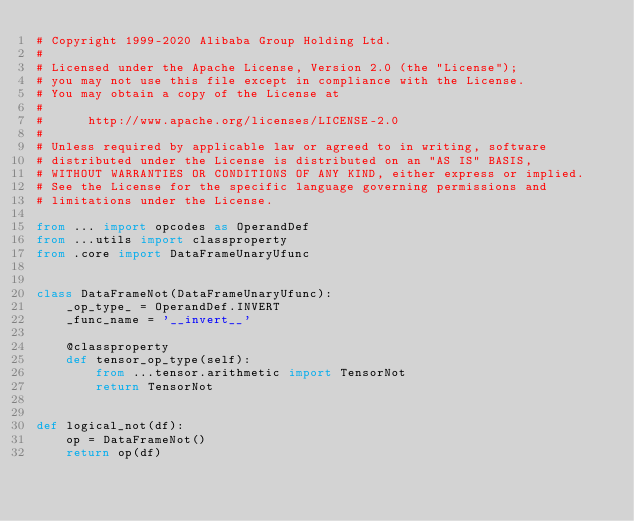Convert code to text. <code><loc_0><loc_0><loc_500><loc_500><_Python_># Copyright 1999-2020 Alibaba Group Holding Ltd.
#
# Licensed under the Apache License, Version 2.0 (the "License");
# you may not use this file except in compliance with the License.
# You may obtain a copy of the License at
#
#      http://www.apache.org/licenses/LICENSE-2.0
#
# Unless required by applicable law or agreed to in writing, software
# distributed under the License is distributed on an "AS IS" BASIS,
# WITHOUT WARRANTIES OR CONDITIONS OF ANY KIND, either express or implied.
# See the License for the specific language governing permissions and
# limitations under the License.

from ... import opcodes as OperandDef
from ...utils import classproperty
from .core import DataFrameUnaryUfunc


class DataFrameNot(DataFrameUnaryUfunc):
    _op_type_ = OperandDef.INVERT
    _func_name = '__invert__'

    @classproperty
    def tensor_op_type(self):
        from ...tensor.arithmetic import TensorNot
        return TensorNot


def logical_not(df):
    op = DataFrameNot()
    return op(df)
</code> 